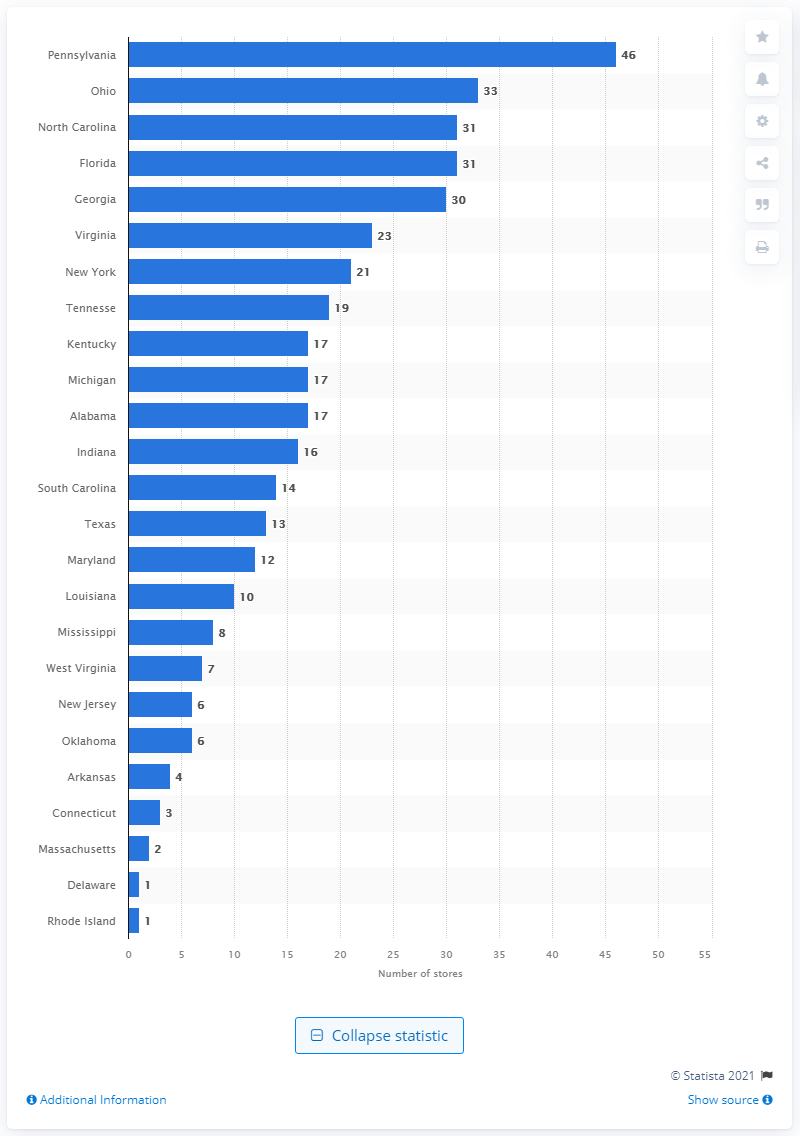Give some essential details in this illustration. As of January 30, 2021, Ollie's Bargain Outlet had a total of 46 stores in the state of Pennsylvania. Ollie's Bargain Outlet had 13 stores in the state of Texas. 